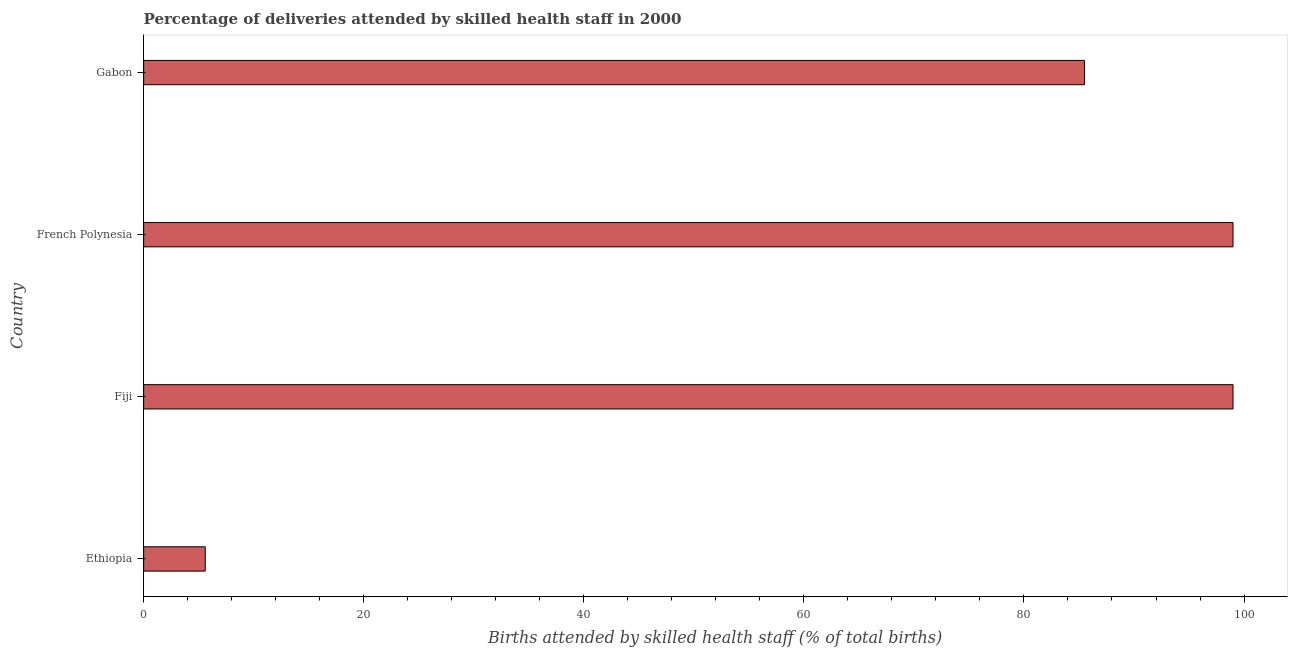What is the title of the graph?
Provide a short and direct response. Percentage of deliveries attended by skilled health staff in 2000. What is the label or title of the X-axis?
Provide a short and direct response. Births attended by skilled health staff (% of total births). What is the number of births attended by skilled health staff in Ethiopia?
Provide a short and direct response. 5.6. In which country was the number of births attended by skilled health staff maximum?
Keep it short and to the point. Fiji. In which country was the number of births attended by skilled health staff minimum?
Keep it short and to the point. Ethiopia. What is the sum of the number of births attended by skilled health staff?
Offer a terse response. 289.1. What is the difference between the number of births attended by skilled health staff in Ethiopia and French Polynesia?
Your answer should be compact. -93.4. What is the average number of births attended by skilled health staff per country?
Your response must be concise. 72.28. What is the median number of births attended by skilled health staff?
Ensure brevity in your answer.  92.25. Is the number of births attended by skilled health staff in Ethiopia less than that in French Polynesia?
Keep it short and to the point. Yes. What is the difference between the highest and the lowest number of births attended by skilled health staff?
Make the answer very short. 93.4. Are the values on the major ticks of X-axis written in scientific E-notation?
Offer a terse response. No. What is the Births attended by skilled health staff (% of total births) of Ethiopia?
Keep it short and to the point. 5.6. What is the Births attended by skilled health staff (% of total births) of Fiji?
Give a very brief answer. 99. What is the Births attended by skilled health staff (% of total births) in French Polynesia?
Your response must be concise. 99. What is the Births attended by skilled health staff (% of total births) in Gabon?
Make the answer very short. 85.5. What is the difference between the Births attended by skilled health staff (% of total births) in Ethiopia and Fiji?
Offer a very short reply. -93.4. What is the difference between the Births attended by skilled health staff (% of total births) in Ethiopia and French Polynesia?
Your answer should be compact. -93.4. What is the difference between the Births attended by skilled health staff (% of total births) in Ethiopia and Gabon?
Your response must be concise. -79.9. What is the difference between the Births attended by skilled health staff (% of total births) in Fiji and French Polynesia?
Offer a very short reply. 0. What is the ratio of the Births attended by skilled health staff (% of total births) in Ethiopia to that in Fiji?
Keep it short and to the point. 0.06. What is the ratio of the Births attended by skilled health staff (% of total births) in Ethiopia to that in French Polynesia?
Keep it short and to the point. 0.06. What is the ratio of the Births attended by skilled health staff (% of total births) in Ethiopia to that in Gabon?
Your answer should be compact. 0.07. What is the ratio of the Births attended by skilled health staff (% of total births) in Fiji to that in Gabon?
Keep it short and to the point. 1.16. What is the ratio of the Births attended by skilled health staff (% of total births) in French Polynesia to that in Gabon?
Provide a short and direct response. 1.16. 